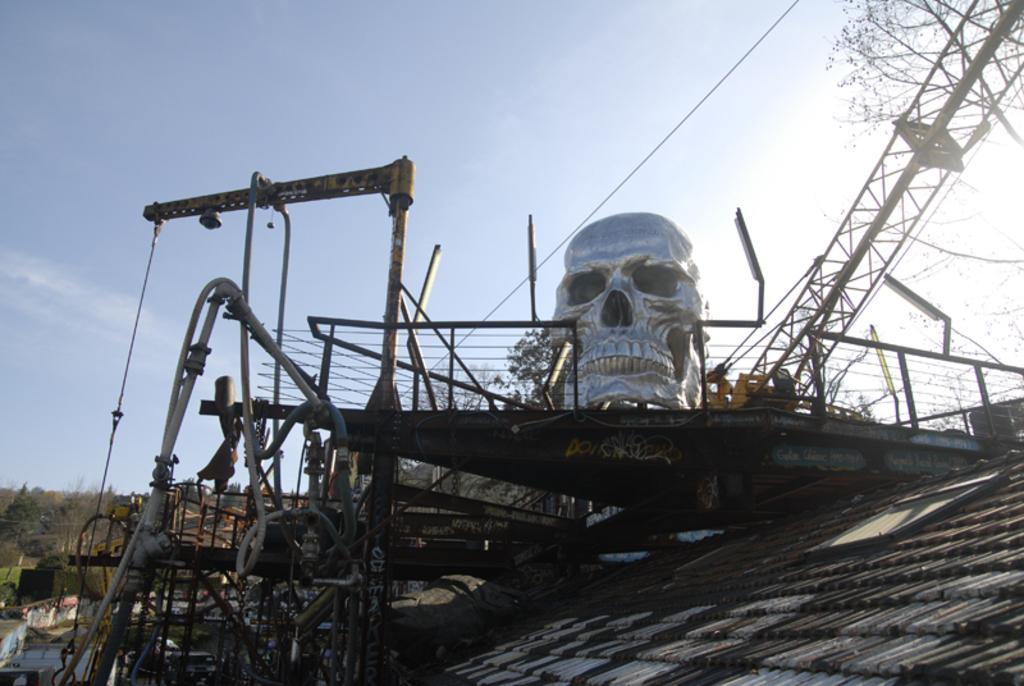What is the main subject of the sculpture in the image? There is a sculpture of a skull in the image. What type of machinery can be seen in the image? There is a crane in the image. What are the long, thin objects in the image? There are rods in the image. What are the long, hollow objects in the image? There are tubes in the image. What is covering the top of the structure in the image? There is a roof in the image. What type of natural elements can be seen in the background of the image? There are trees in the background of the image. How many cakes are being served by the fairies in the image? There are no cakes or fairies present in the image. What type of boundary is visible in the image? There is no boundary visible in the image. 